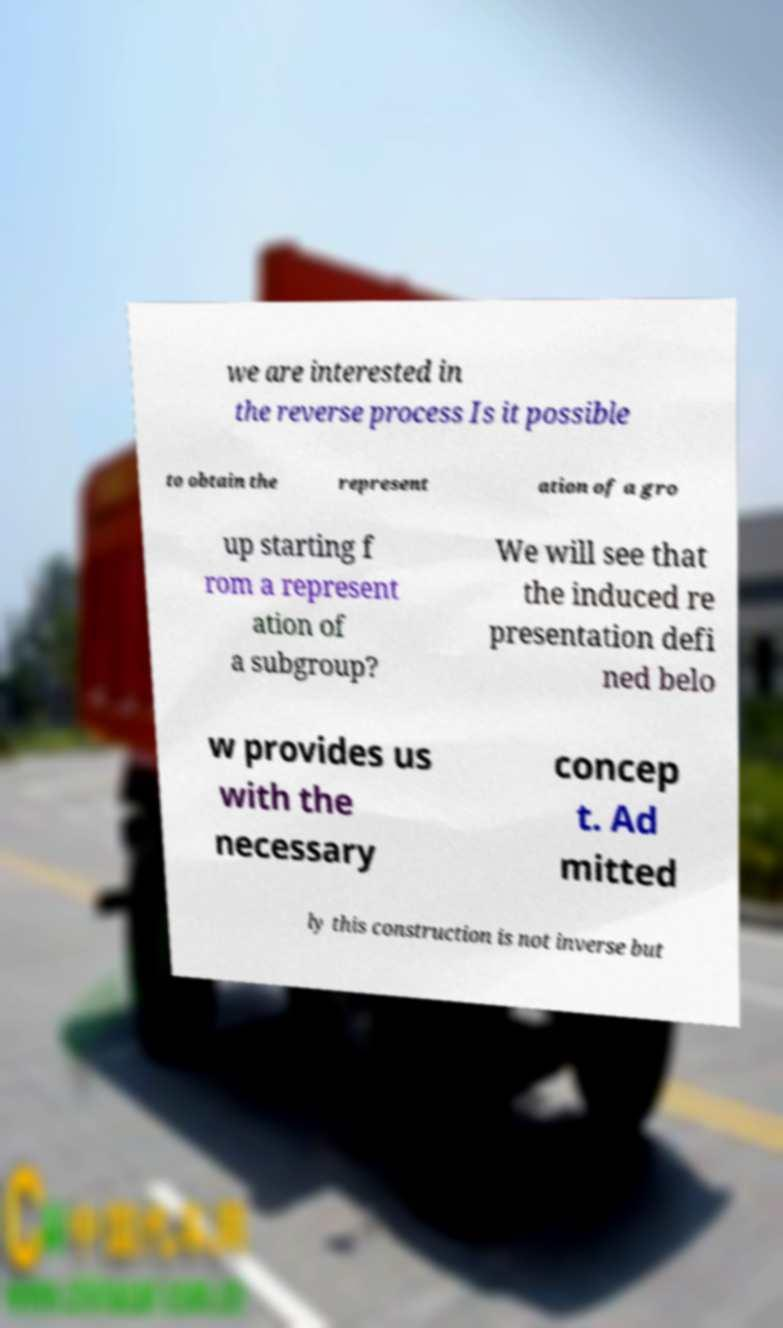Could you extract and type out the text from this image? we are interested in the reverse process Is it possible to obtain the represent ation of a gro up starting f rom a represent ation of a subgroup? We will see that the induced re presentation defi ned belo w provides us with the necessary concep t. Ad mitted ly this construction is not inverse but 